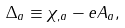Convert formula to latex. <formula><loc_0><loc_0><loc_500><loc_500>\Delta _ { a } \equiv \chi _ { , a } - e A _ { a } ,</formula> 